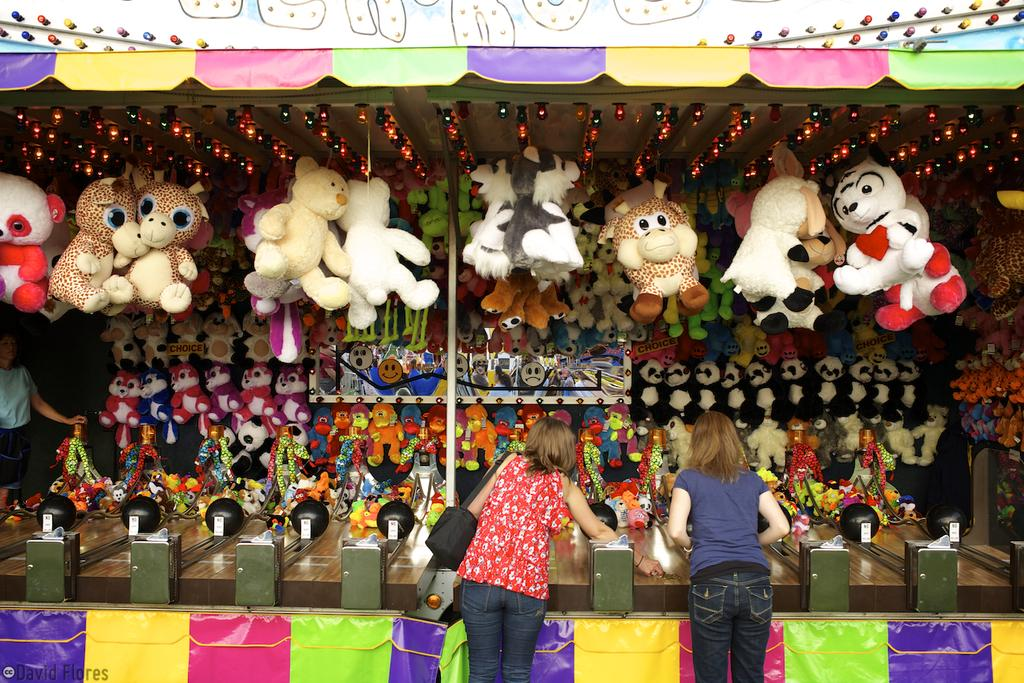How many people are in the image? There are two persons standing in the image. What are the persons wearing? The persons are wearing black color bags. What can be seen in front of the persons? There is a group of toys in front of the persons. What is the color of the toys? The toys are in different colors. What else is visible in the image? There is a pole visible in the image. How many ducks are sitting on the twig in the image? There are no ducks or twigs present in the image. What is the condition of the persons' throats in the image? There is no information about the condition of the persons' throats in the image. 